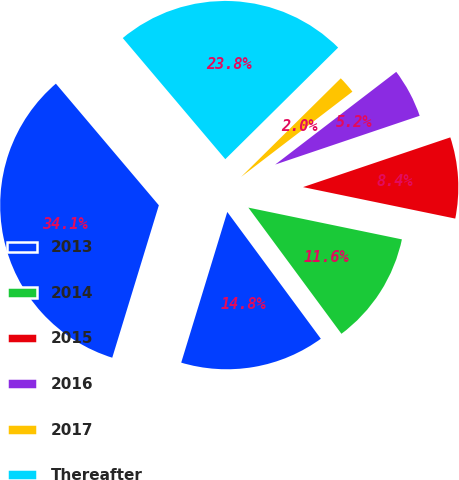<chart> <loc_0><loc_0><loc_500><loc_500><pie_chart><fcel>2013<fcel>2014<fcel>2015<fcel>2016<fcel>2017<fcel>Thereafter<fcel>Total<nl><fcel>14.84%<fcel>11.64%<fcel>8.43%<fcel>5.22%<fcel>2.01%<fcel>23.77%<fcel>34.1%<nl></chart> 